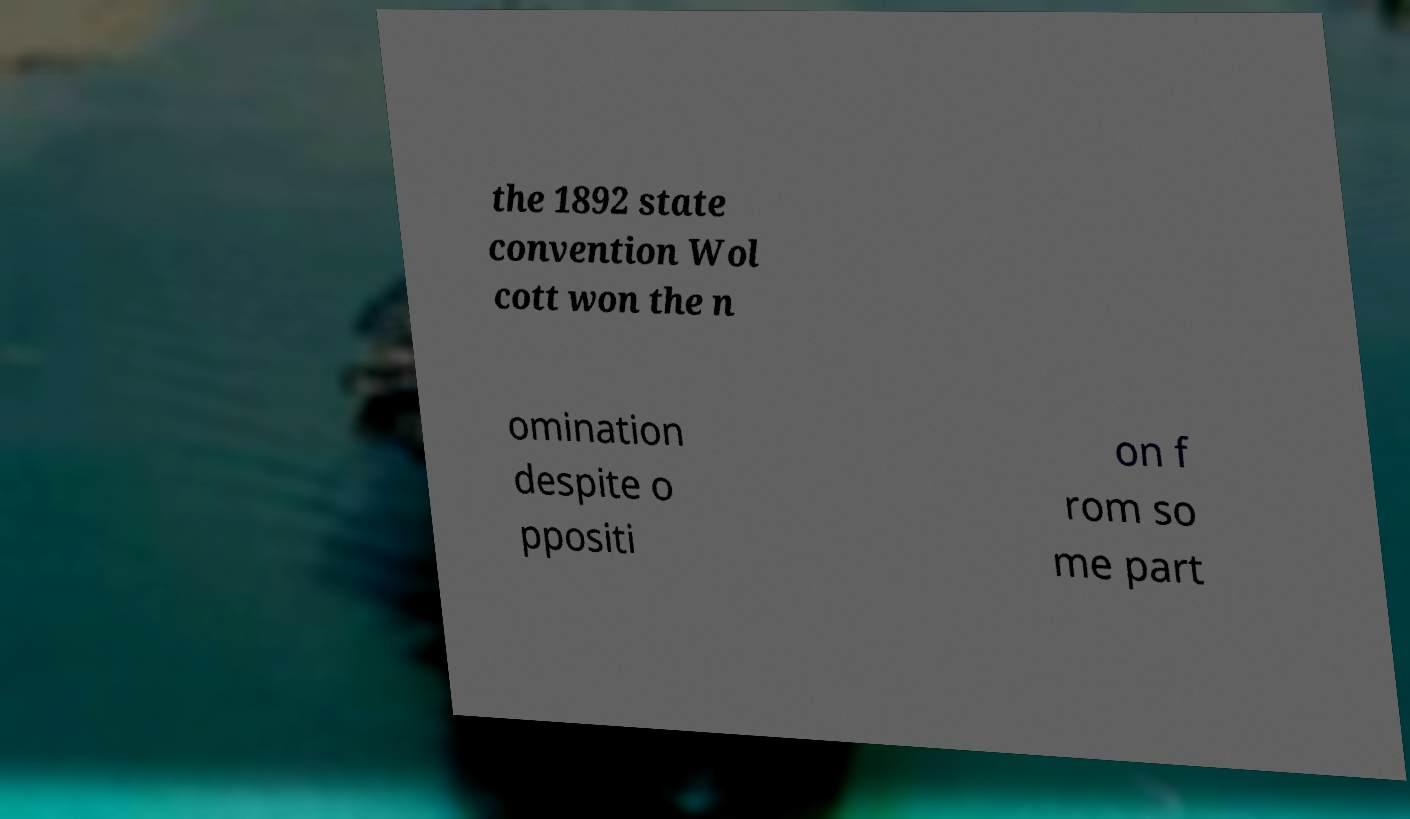Please identify and transcribe the text found in this image. the 1892 state convention Wol cott won the n omination despite o ppositi on f rom so me part 